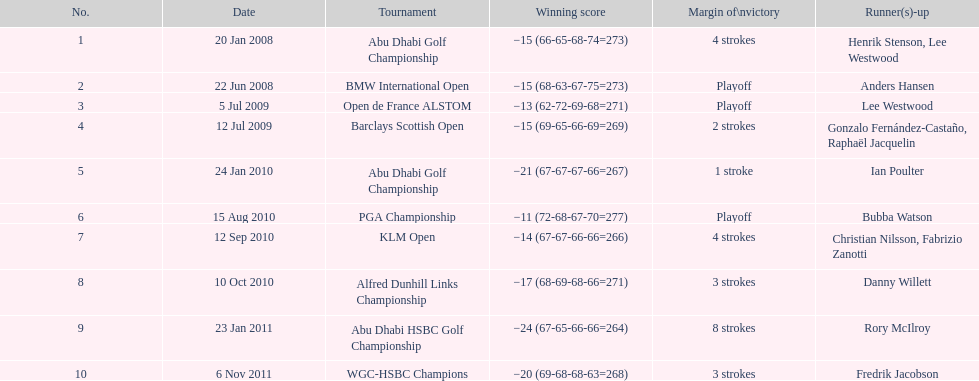How many more strokes were in the klm open than the barclays scottish open? 2 strokes. 